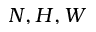<formula> <loc_0><loc_0><loc_500><loc_500>N , H , W</formula> 